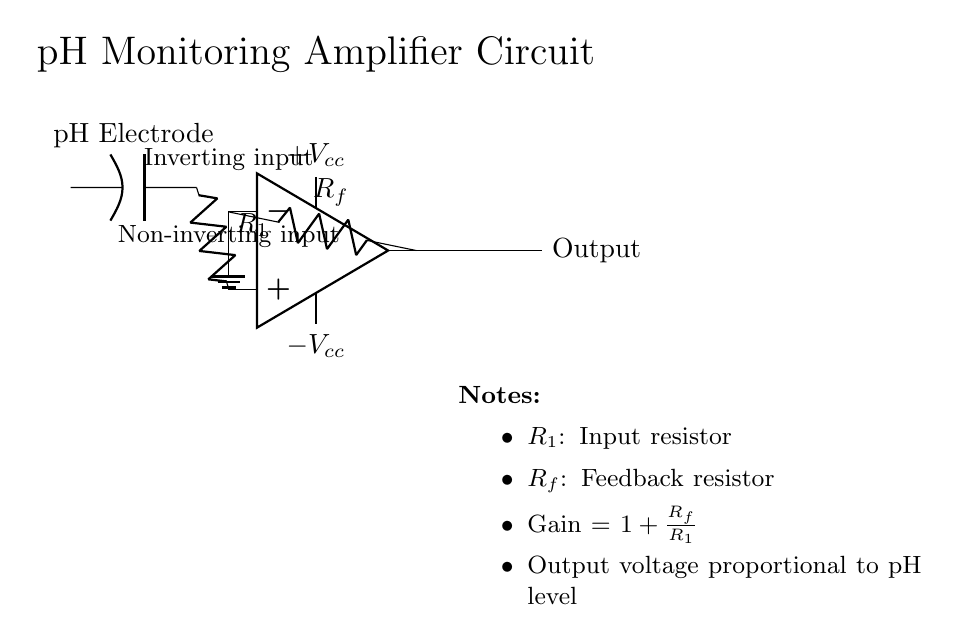What type of amplifier is shown in the circuit? The circuit utilizes an operational amplifier (op-amp), which is specifically designed for signal processing and amplification tasks.
Answer: Operational amplifier What component represents the pH sensor? The pH sensor is represented by the labeled pH Electrode in the circuit diagram, which is the device that will measure the acidity or alkalinity of the solution.
Answer: pH Electrode What do the resistors R1 and Rf control in this circuit? Resistors R1 and Rf determine the gain of the amplifier circuit, which affects how much the input signal is amplified at the output. Gain can be calculated using the formula Gain = 1 + Rf/R1.
Answer: Gain What are the supply voltages labeled in the circuit? The power supply voltages are labeled as +Vcc for positive voltage and -Vcc for negative voltage. These provide the necessary power for the op-amp to function effectively.
Answer: +Vcc and -Vcc How is the output voltage related to pH level? The output voltage is proportional to the pH level, meaning that as the pH level changes, the output voltage will vary accordingly. This relationship allows for the monitoring of pH levels in the hydroponic system effectively.
Answer: Proportional What direction does the current flow towards the ground from the inverting input? The current flows from the inverting input towards the ground when connected; this is indicated by the downward line leading to the ground symbol in the circuit diagram.
Answer: Downward What happens when Rf is increased in value? Increasing Rf will increase the gain of the amplifier configuration, resulting in a higher output voltage for the same input signal, thereby amplifying the measured pH levels more significantly.
Answer: Increased gain 